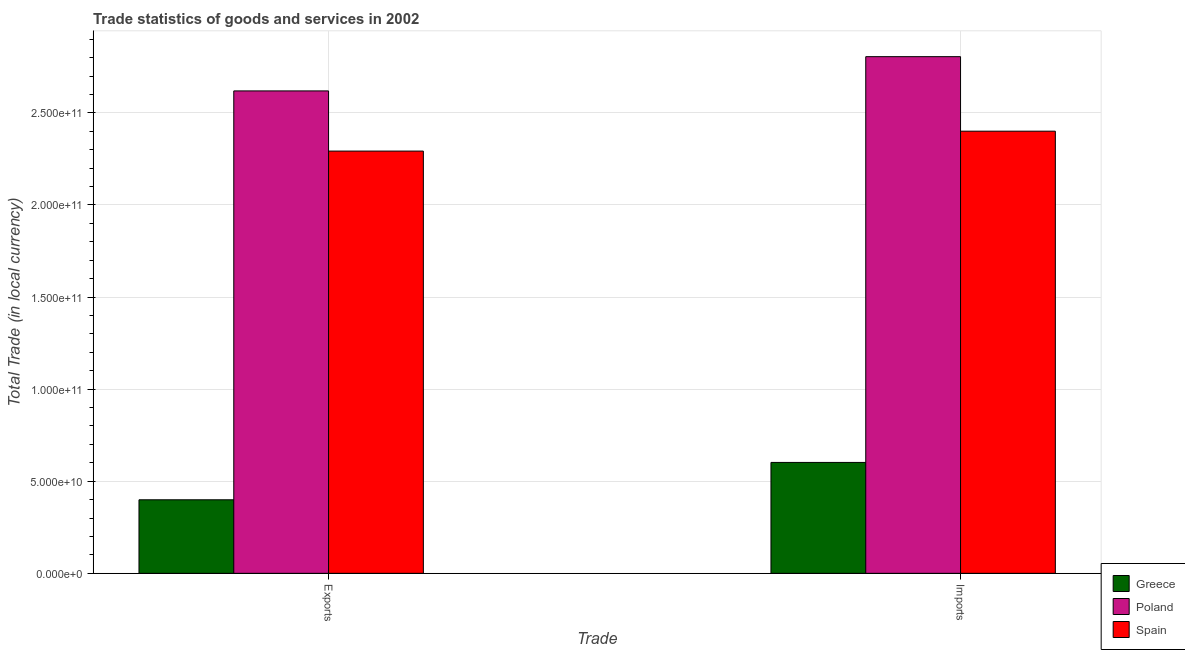How many groups of bars are there?
Your response must be concise. 2. Are the number of bars on each tick of the X-axis equal?
Offer a very short reply. Yes. How many bars are there on the 2nd tick from the left?
Provide a succinct answer. 3. How many bars are there on the 1st tick from the right?
Your answer should be very brief. 3. What is the label of the 2nd group of bars from the left?
Provide a short and direct response. Imports. What is the export of goods and services in Greece?
Keep it short and to the point. 3.99e+1. Across all countries, what is the maximum export of goods and services?
Offer a terse response. 2.62e+11. Across all countries, what is the minimum export of goods and services?
Give a very brief answer. 3.99e+1. In which country was the imports of goods and services maximum?
Your answer should be compact. Poland. In which country was the imports of goods and services minimum?
Your answer should be compact. Greece. What is the total export of goods and services in the graph?
Your response must be concise. 5.31e+11. What is the difference between the export of goods and services in Spain and that in Greece?
Keep it short and to the point. 1.89e+11. What is the difference between the imports of goods and services in Spain and the export of goods and services in Greece?
Provide a succinct answer. 2.00e+11. What is the average imports of goods and services per country?
Offer a terse response. 1.94e+11. What is the difference between the imports of goods and services and export of goods and services in Spain?
Keep it short and to the point. 1.08e+1. In how many countries, is the export of goods and services greater than 190000000000 LCU?
Provide a short and direct response. 2. What is the ratio of the export of goods and services in Poland to that in Greece?
Give a very brief answer. 6.56. In how many countries, is the export of goods and services greater than the average export of goods and services taken over all countries?
Your answer should be very brief. 2. How many bars are there?
Provide a succinct answer. 6. Does the graph contain any zero values?
Your answer should be very brief. No. Does the graph contain grids?
Your answer should be very brief. Yes. Where does the legend appear in the graph?
Give a very brief answer. Bottom right. How many legend labels are there?
Give a very brief answer. 3. How are the legend labels stacked?
Your answer should be compact. Vertical. What is the title of the graph?
Keep it short and to the point. Trade statistics of goods and services in 2002. Does "Samoa" appear as one of the legend labels in the graph?
Offer a terse response. No. What is the label or title of the X-axis?
Provide a succinct answer. Trade. What is the label or title of the Y-axis?
Provide a succinct answer. Total Trade (in local currency). What is the Total Trade (in local currency) in Greece in Exports?
Your answer should be very brief. 3.99e+1. What is the Total Trade (in local currency) of Poland in Exports?
Offer a very short reply. 2.62e+11. What is the Total Trade (in local currency) of Spain in Exports?
Your response must be concise. 2.29e+11. What is the Total Trade (in local currency) of Greece in Imports?
Provide a succinct answer. 6.02e+1. What is the Total Trade (in local currency) of Poland in Imports?
Offer a very short reply. 2.81e+11. What is the Total Trade (in local currency) of Spain in Imports?
Provide a succinct answer. 2.40e+11. Across all Trade, what is the maximum Total Trade (in local currency) of Greece?
Ensure brevity in your answer.  6.02e+1. Across all Trade, what is the maximum Total Trade (in local currency) of Poland?
Keep it short and to the point. 2.81e+11. Across all Trade, what is the maximum Total Trade (in local currency) of Spain?
Keep it short and to the point. 2.40e+11. Across all Trade, what is the minimum Total Trade (in local currency) in Greece?
Keep it short and to the point. 3.99e+1. Across all Trade, what is the minimum Total Trade (in local currency) in Poland?
Give a very brief answer. 2.62e+11. Across all Trade, what is the minimum Total Trade (in local currency) of Spain?
Offer a terse response. 2.29e+11. What is the total Total Trade (in local currency) of Greece in the graph?
Ensure brevity in your answer.  1.00e+11. What is the total Total Trade (in local currency) in Poland in the graph?
Provide a short and direct response. 5.42e+11. What is the total Total Trade (in local currency) in Spain in the graph?
Provide a short and direct response. 4.69e+11. What is the difference between the Total Trade (in local currency) of Greece in Exports and that in Imports?
Keep it short and to the point. -2.03e+1. What is the difference between the Total Trade (in local currency) in Poland in Exports and that in Imports?
Your response must be concise. -1.86e+1. What is the difference between the Total Trade (in local currency) in Spain in Exports and that in Imports?
Provide a succinct answer. -1.08e+1. What is the difference between the Total Trade (in local currency) of Greece in Exports and the Total Trade (in local currency) of Poland in Imports?
Give a very brief answer. -2.41e+11. What is the difference between the Total Trade (in local currency) of Greece in Exports and the Total Trade (in local currency) of Spain in Imports?
Give a very brief answer. -2.00e+11. What is the difference between the Total Trade (in local currency) of Poland in Exports and the Total Trade (in local currency) of Spain in Imports?
Ensure brevity in your answer.  2.19e+1. What is the average Total Trade (in local currency) in Greece per Trade?
Make the answer very short. 5.01e+1. What is the average Total Trade (in local currency) in Poland per Trade?
Offer a very short reply. 2.71e+11. What is the average Total Trade (in local currency) of Spain per Trade?
Make the answer very short. 2.35e+11. What is the difference between the Total Trade (in local currency) in Greece and Total Trade (in local currency) in Poland in Exports?
Give a very brief answer. -2.22e+11. What is the difference between the Total Trade (in local currency) in Greece and Total Trade (in local currency) in Spain in Exports?
Ensure brevity in your answer.  -1.89e+11. What is the difference between the Total Trade (in local currency) in Poland and Total Trade (in local currency) in Spain in Exports?
Provide a short and direct response. 3.27e+1. What is the difference between the Total Trade (in local currency) in Greece and Total Trade (in local currency) in Poland in Imports?
Offer a terse response. -2.20e+11. What is the difference between the Total Trade (in local currency) of Greece and Total Trade (in local currency) of Spain in Imports?
Give a very brief answer. -1.80e+11. What is the difference between the Total Trade (in local currency) in Poland and Total Trade (in local currency) in Spain in Imports?
Make the answer very short. 4.05e+1. What is the ratio of the Total Trade (in local currency) in Greece in Exports to that in Imports?
Offer a terse response. 0.66. What is the ratio of the Total Trade (in local currency) of Poland in Exports to that in Imports?
Make the answer very short. 0.93. What is the ratio of the Total Trade (in local currency) of Spain in Exports to that in Imports?
Give a very brief answer. 0.95. What is the difference between the highest and the second highest Total Trade (in local currency) of Greece?
Provide a succinct answer. 2.03e+1. What is the difference between the highest and the second highest Total Trade (in local currency) in Poland?
Your response must be concise. 1.86e+1. What is the difference between the highest and the second highest Total Trade (in local currency) in Spain?
Your answer should be very brief. 1.08e+1. What is the difference between the highest and the lowest Total Trade (in local currency) in Greece?
Ensure brevity in your answer.  2.03e+1. What is the difference between the highest and the lowest Total Trade (in local currency) in Poland?
Provide a succinct answer. 1.86e+1. What is the difference between the highest and the lowest Total Trade (in local currency) of Spain?
Your answer should be compact. 1.08e+1. 